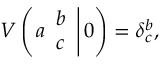<formula> <loc_0><loc_0><loc_500><loc_500>V \left ( a \begin{array} { c } { b } \\ { c } \end{array} \right | 0 \right ) = \delta _ { c } ^ { b } ,</formula> 